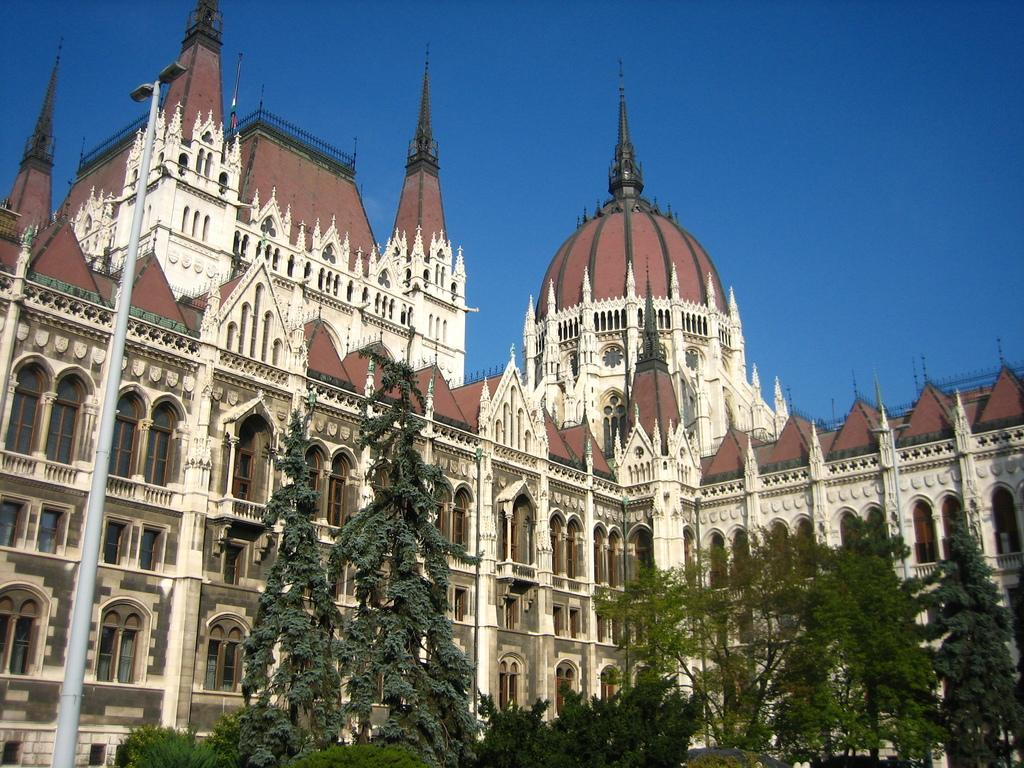What type of vegetation can be seen in the image? There are trees in the image. What color are the trees? The trees are green. What can be seen in the background of the image? There are buildings in the background of the image. What colors are the buildings? The buildings are brown and white. What color is the sky in the image? The sky is blue. How many stems can be seen on the trees in the image? There is no mention of stems in the provided facts, and therefore it cannot be determined from the image. 